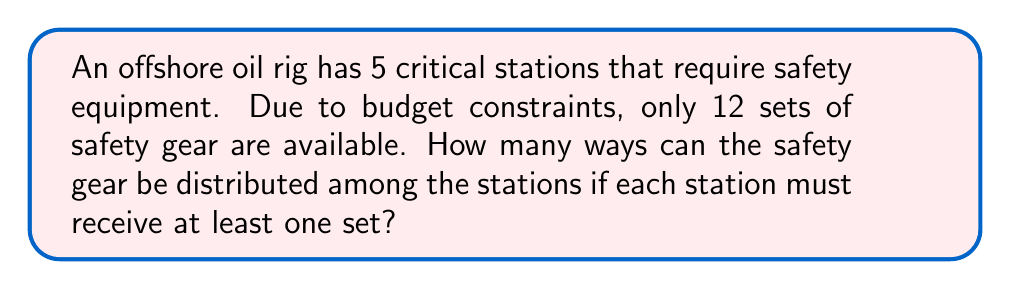Could you help me with this problem? Let's approach this step-by-step using the stars and bars method:

1) First, we need to ensure each station gets at least one set. So, we distribute 5 sets, one to each station.

2) Now we have 7 sets left to distribute (12 - 5 = 7).

3) This problem can be rephrased as: "In how many ways can we put 7 identical objects into 5 distinct boxes?"

4) This is a classic stars and bars problem. The formula for this is:

   $$\binom{n+k-1}{k-1}$$

   Where n is the number of identical objects and k is the number of distinct boxes.

5) In our case, n = 7 (remaining sets) and k = 5 (stations).

6) Plugging into the formula:

   $$\binom{7+5-1}{5-1} = \binom{11}{4}$$

7) We can calculate this:

   $$\binom{11}{4} = \frac{11!}{4!(11-4)!} = \frac{11!}{4!7!} = 330$$

Therefore, there are 330 ways to distribute the safety gear.
Answer: 330 